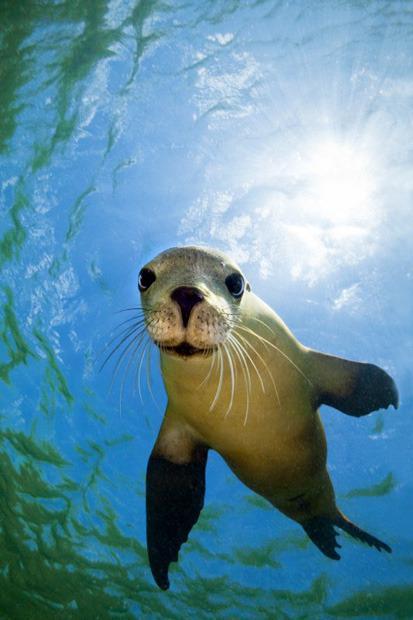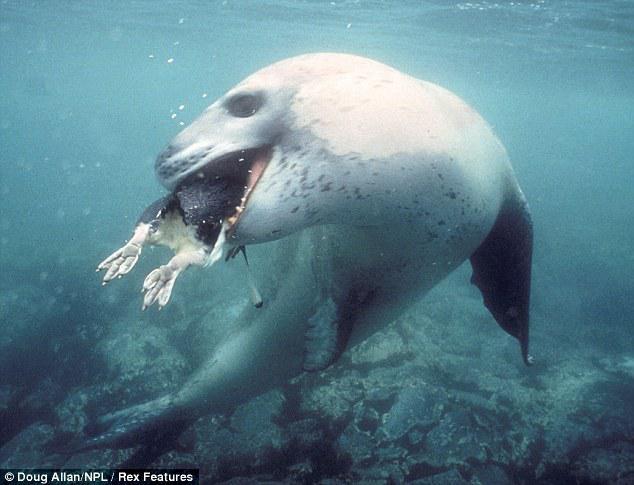The first image is the image on the left, the second image is the image on the right. Assess this claim about the two images: "A total of two seals are shown, all of them swimming underwater, and one seal is swimming forward and eyeing the camera.". Correct or not? Answer yes or no. Yes. The first image is the image on the left, the second image is the image on the right. Analyze the images presented: Is the assertion "There are at least two seals in the right image swimming underwater." valid? Answer yes or no. No. 